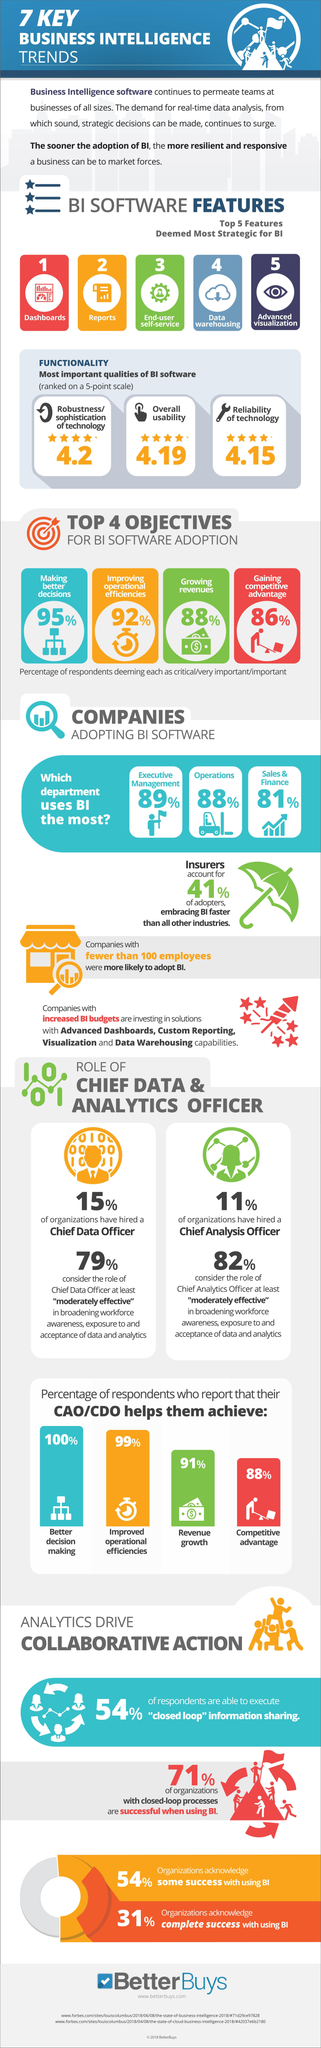What percentage of organizations have not hired a Chief Data Officer?
Answer the question with a short phrase. 85% What percentage of respondents consider adopting BI software is very critical in making better decisions? 95% What percentage of sales & finance companies use BI software? 81% What is the overall usability of BI software ranked on a 5-point scale? 4.19 What is the overall reliability of BI software ranked on a 5-point scale? 4.15 What percentage of respondents consider adopting BI software  is very critical in growing revenues? 88% What percentage of respondents consider adopting BI software is very critical in improving operational efficiencies? 92% What percentage of executive management companies do not use BI software? 11% 